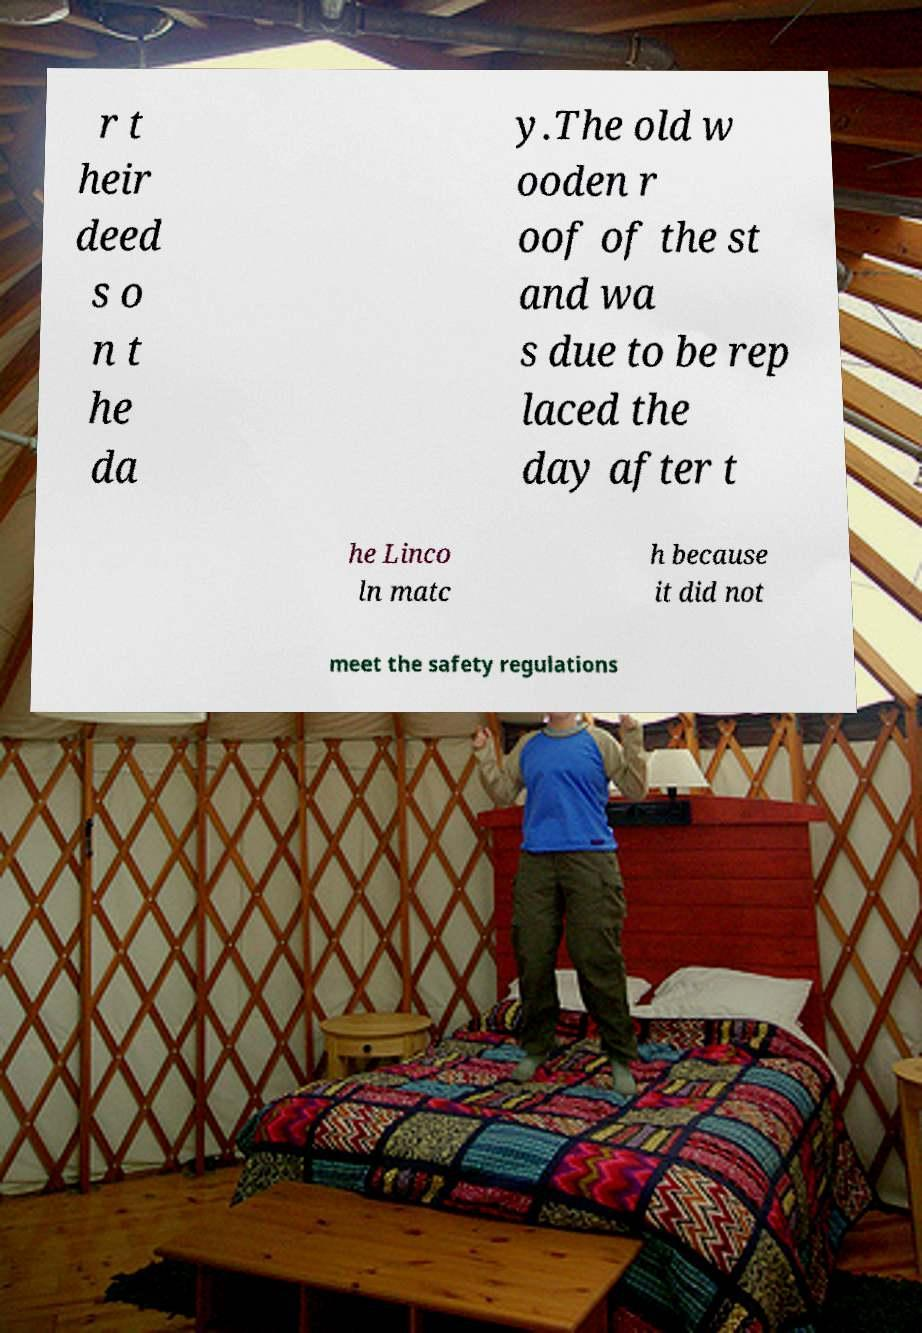Can you read and provide the text displayed in the image?This photo seems to have some interesting text. Can you extract and type it out for me? r t heir deed s o n t he da y.The old w ooden r oof of the st and wa s due to be rep laced the day after t he Linco ln matc h because it did not meet the safety regulations 